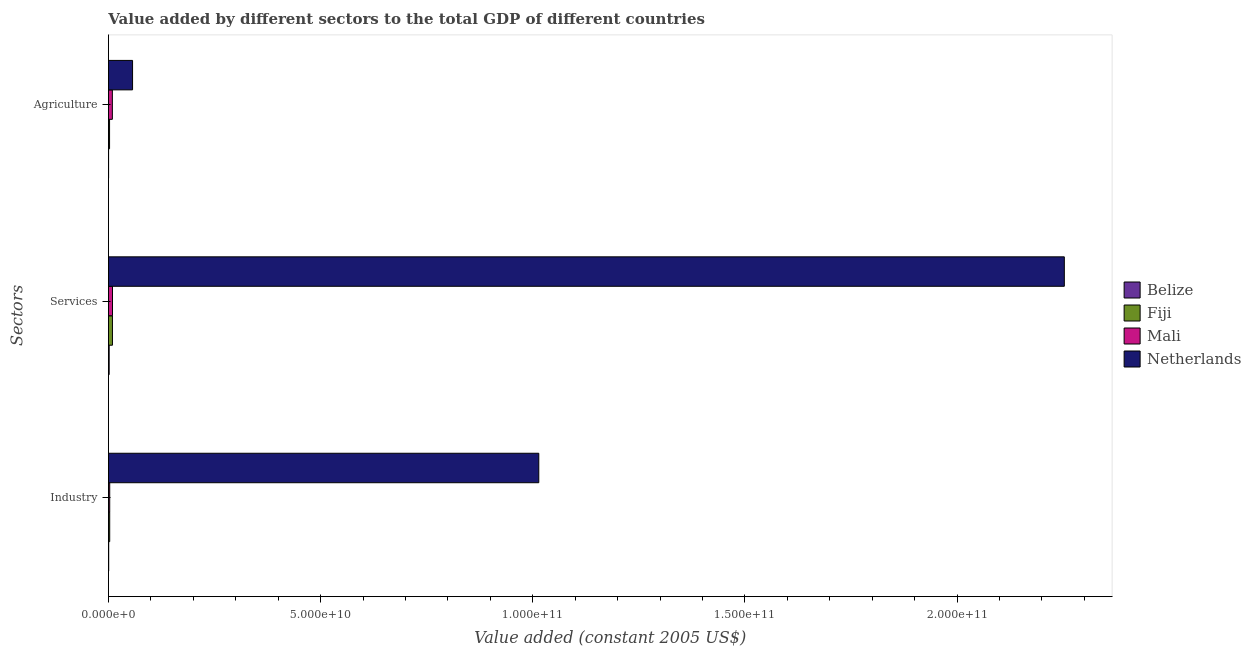How many different coloured bars are there?
Keep it short and to the point. 4. How many bars are there on the 2nd tick from the bottom?
Provide a short and direct response. 4. What is the label of the 2nd group of bars from the top?
Ensure brevity in your answer.  Services. What is the value added by services in Fiji?
Give a very brief answer. 9.49e+08. Across all countries, what is the maximum value added by industrial sector?
Offer a very short reply. 1.01e+11. Across all countries, what is the minimum value added by industrial sector?
Make the answer very short. 6.44e+07. In which country was the value added by industrial sector minimum?
Give a very brief answer. Belize. What is the total value added by services in the graph?
Offer a very short reply. 2.27e+11. What is the difference between the value added by services in Fiji and that in Belize?
Your response must be concise. 7.75e+08. What is the difference between the value added by services in Mali and the value added by industrial sector in Netherlands?
Give a very brief answer. -1.00e+11. What is the average value added by industrial sector per country?
Provide a succinct answer. 2.55e+1. What is the difference between the value added by agricultural sector and value added by industrial sector in Fiji?
Provide a succinct answer. -3.22e+07. What is the ratio of the value added by services in Fiji to that in Mali?
Offer a terse response. 0.99. What is the difference between the highest and the second highest value added by services?
Keep it short and to the point. 2.24e+11. What is the difference between the highest and the lowest value added by services?
Give a very brief answer. 2.25e+11. In how many countries, is the value added by agricultural sector greater than the average value added by agricultural sector taken over all countries?
Offer a very short reply. 1. What does the 2nd bar from the top in Services represents?
Keep it short and to the point. Mali. What does the 1st bar from the bottom in Industry represents?
Provide a succinct answer. Belize. How many countries are there in the graph?
Keep it short and to the point. 4. What is the difference between two consecutive major ticks on the X-axis?
Your response must be concise. 5.00e+1. Does the graph contain any zero values?
Provide a short and direct response. No. Does the graph contain grids?
Ensure brevity in your answer.  No. Where does the legend appear in the graph?
Provide a succinct answer. Center right. What is the title of the graph?
Your answer should be very brief. Value added by different sectors to the total GDP of different countries. Does "Canada" appear as one of the legend labels in the graph?
Offer a terse response. No. What is the label or title of the X-axis?
Make the answer very short. Value added (constant 2005 US$). What is the label or title of the Y-axis?
Ensure brevity in your answer.  Sectors. What is the Value added (constant 2005 US$) of Belize in Industry?
Provide a succinct answer. 6.44e+07. What is the Value added (constant 2005 US$) of Fiji in Industry?
Ensure brevity in your answer.  3.01e+08. What is the Value added (constant 2005 US$) in Mali in Industry?
Keep it short and to the point. 3.04e+08. What is the Value added (constant 2005 US$) in Netherlands in Industry?
Ensure brevity in your answer.  1.01e+11. What is the Value added (constant 2005 US$) in Belize in Services?
Ensure brevity in your answer.  1.75e+08. What is the Value added (constant 2005 US$) of Fiji in Services?
Offer a terse response. 9.49e+08. What is the Value added (constant 2005 US$) of Mali in Services?
Your answer should be very brief. 9.58e+08. What is the Value added (constant 2005 US$) in Netherlands in Services?
Offer a very short reply. 2.25e+11. What is the Value added (constant 2005 US$) in Belize in Agriculture?
Ensure brevity in your answer.  3.76e+07. What is the Value added (constant 2005 US$) of Fiji in Agriculture?
Your response must be concise. 2.69e+08. What is the Value added (constant 2005 US$) of Mali in Agriculture?
Keep it short and to the point. 9.25e+08. What is the Value added (constant 2005 US$) in Netherlands in Agriculture?
Offer a terse response. 5.69e+09. Across all Sectors, what is the maximum Value added (constant 2005 US$) of Belize?
Offer a terse response. 1.75e+08. Across all Sectors, what is the maximum Value added (constant 2005 US$) in Fiji?
Offer a very short reply. 9.49e+08. Across all Sectors, what is the maximum Value added (constant 2005 US$) of Mali?
Offer a very short reply. 9.58e+08. Across all Sectors, what is the maximum Value added (constant 2005 US$) of Netherlands?
Ensure brevity in your answer.  2.25e+11. Across all Sectors, what is the minimum Value added (constant 2005 US$) of Belize?
Make the answer very short. 3.76e+07. Across all Sectors, what is the minimum Value added (constant 2005 US$) of Fiji?
Your answer should be very brief. 2.69e+08. Across all Sectors, what is the minimum Value added (constant 2005 US$) of Mali?
Offer a very short reply. 3.04e+08. Across all Sectors, what is the minimum Value added (constant 2005 US$) in Netherlands?
Your response must be concise. 5.69e+09. What is the total Value added (constant 2005 US$) of Belize in the graph?
Your answer should be very brief. 2.76e+08. What is the total Value added (constant 2005 US$) of Fiji in the graph?
Your answer should be compact. 1.52e+09. What is the total Value added (constant 2005 US$) in Mali in the graph?
Offer a very short reply. 2.19e+09. What is the total Value added (constant 2005 US$) in Netherlands in the graph?
Your response must be concise. 3.32e+11. What is the difference between the Value added (constant 2005 US$) of Belize in Industry and that in Services?
Offer a very short reply. -1.10e+08. What is the difference between the Value added (constant 2005 US$) in Fiji in Industry and that in Services?
Keep it short and to the point. -6.49e+08. What is the difference between the Value added (constant 2005 US$) in Mali in Industry and that in Services?
Keep it short and to the point. -6.53e+08. What is the difference between the Value added (constant 2005 US$) of Netherlands in Industry and that in Services?
Provide a short and direct response. -1.24e+11. What is the difference between the Value added (constant 2005 US$) of Belize in Industry and that in Agriculture?
Your response must be concise. 2.68e+07. What is the difference between the Value added (constant 2005 US$) in Fiji in Industry and that in Agriculture?
Provide a succinct answer. 3.22e+07. What is the difference between the Value added (constant 2005 US$) in Mali in Industry and that in Agriculture?
Your answer should be compact. -6.21e+08. What is the difference between the Value added (constant 2005 US$) of Netherlands in Industry and that in Agriculture?
Keep it short and to the point. 9.57e+1. What is the difference between the Value added (constant 2005 US$) in Belize in Services and that in Agriculture?
Ensure brevity in your answer.  1.37e+08. What is the difference between the Value added (constant 2005 US$) of Fiji in Services and that in Agriculture?
Provide a succinct answer. 6.81e+08. What is the difference between the Value added (constant 2005 US$) in Mali in Services and that in Agriculture?
Offer a terse response. 3.22e+07. What is the difference between the Value added (constant 2005 US$) of Netherlands in Services and that in Agriculture?
Your answer should be very brief. 2.20e+11. What is the difference between the Value added (constant 2005 US$) of Belize in Industry and the Value added (constant 2005 US$) of Fiji in Services?
Ensure brevity in your answer.  -8.85e+08. What is the difference between the Value added (constant 2005 US$) in Belize in Industry and the Value added (constant 2005 US$) in Mali in Services?
Your answer should be compact. -8.93e+08. What is the difference between the Value added (constant 2005 US$) in Belize in Industry and the Value added (constant 2005 US$) in Netherlands in Services?
Give a very brief answer. -2.25e+11. What is the difference between the Value added (constant 2005 US$) of Fiji in Industry and the Value added (constant 2005 US$) of Mali in Services?
Make the answer very short. -6.57e+08. What is the difference between the Value added (constant 2005 US$) of Fiji in Industry and the Value added (constant 2005 US$) of Netherlands in Services?
Your answer should be compact. -2.25e+11. What is the difference between the Value added (constant 2005 US$) of Mali in Industry and the Value added (constant 2005 US$) of Netherlands in Services?
Your response must be concise. -2.25e+11. What is the difference between the Value added (constant 2005 US$) in Belize in Industry and the Value added (constant 2005 US$) in Fiji in Agriculture?
Your answer should be very brief. -2.04e+08. What is the difference between the Value added (constant 2005 US$) in Belize in Industry and the Value added (constant 2005 US$) in Mali in Agriculture?
Offer a very short reply. -8.61e+08. What is the difference between the Value added (constant 2005 US$) in Belize in Industry and the Value added (constant 2005 US$) in Netherlands in Agriculture?
Ensure brevity in your answer.  -5.62e+09. What is the difference between the Value added (constant 2005 US$) in Fiji in Industry and the Value added (constant 2005 US$) in Mali in Agriculture?
Provide a short and direct response. -6.25e+08. What is the difference between the Value added (constant 2005 US$) in Fiji in Industry and the Value added (constant 2005 US$) in Netherlands in Agriculture?
Provide a short and direct response. -5.39e+09. What is the difference between the Value added (constant 2005 US$) in Mali in Industry and the Value added (constant 2005 US$) in Netherlands in Agriculture?
Your answer should be compact. -5.38e+09. What is the difference between the Value added (constant 2005 US$) in Belize in Services and the Value added (constant 2005 US$) in Fiji in Agriculture?
Provide a short and direct response. -9.41e+07. What is the difference between the Value added (constant 2005 US$) of Belize in Services and the Value added (constant 2005 US$) of Mali in Agriculture?
Offer a terse response. -7.51e+08. What is the difference between the Value added (constant 2005 US$) of Belize in Services and the Value added (constant 2005 US$) of Netherlands in Agriculture?
Provide a short and direct response. -5.51e+09. What is the difference between the Value added (constant 2005 US$) of Fiji in Services and the Value added (constant 2005 US$) of Mali in Agriculture?
Ensure brevity in your answer.  2.41e+07. What is the difference between the Value added (constant 2005 US$) of Fiji in Services and the Value added (constant 2005 US$) of Netherlands in Agriculture?
Provide a short and direct response. -4.74e+09. What is the difference between the Value added (constant 2005 US$) in Mali in Services and the Value added (constant 2005 US$) in Netherlands in Agriculture?
Your response must be concise. -4.73e+09. What is the average Value added (constant 2005 US$) in Belize per Sectors?
Offer a very short reply. 9.22e+07. What is the average Value added (constant 2005 US$) in Fiji per Sectors?
Make the answer very short. 5.06e+08. What is the average Value added (constant 2005 US$) of Mali per Sectors?
Your response must be concise. 7.29e+08. What is the average Value added (constant 2005 US$) of Netherlands per Sectors?
Make the answer very short. 1.11e+11. What is the difference between the Value added (constant 2005 US$) in Belize and Value added (constant 2005 US$) in Fiji in Industry?
Keep it short and to the point. -2.36e+08. What is the difference between the Value added (constant 2005 US$) of Belize and Value added (constant 2005 US$) of Mali in Industry?
Provide a succinct answer. -2.40e+08. What is the difference between the Value added (constant 2005 US$) in Belize and Value added (constant 2005 US$) in Netherlands in Industry?
Your answer should be very brief. -1.01e+11. What is the difference between the Value added (constant 2005 US$) in Fiji and Value added (constant 2005 US$) in Mali in Industry?
Make the answer very short. -3.46e+06. What is the difference between the Value added (constant 2005 US$) in Fiji and Value added (constant 2005 US$) in Netherlands in Industry?
Your response must be concise. -1.01e+11. What is the difference between the Value added (constant 2005 US$) of Mali and Value added (constant 2005 US$) of Netherlands in Industry?
Offer a very short reply. -1.01e+11. What is the difference between the Value added (constant 2005 US$) of Belize and Value added (constant 2005 US$) of Fiji in Services?
Ensure brevity in your answer.  -7.75e+08. What is the difference between the Value added (constant 2005 US$) in Belize and Value added (constant 2005 US$) in Mali in Services?
Offer a terse response. -7.83e+08. What is the difference between the Value added (constant 2005 US$) of Belize and Value added (constant 2005 US$) of Netherlands in Services?
Ensure brevity in your answer.  -2.25e+11. What is the difference between the Value added (constant 2005 US$) of Fiji and Value added (constant 2005 US$) of Mali in Services?
Offer a very short reply. -8.07e+06. What is the difference between the Value added (constant 2005 US$) in Fiji and Value added (constant 2005 US$) in Netherlands in Services?
Make the answer very short. -2.24e+11. What is the difference between the Value added (constant 2005 US$) of Mali and Value added (constant 2005 US$) of Netherlands in Services?
Your answer should be compact. -2.24e+11. What is the difference between the Value added (constant 2005 US$) in Belize and Value added (constant 2005 US$) in Fiji in Agriculture?
Your response must be concise. -2.31e+08. What is the difference between the Value added (constant 2005 US$) of Belize and Value added (constant 2005 US$) of Mali in Agriculture?
Ensure brevity in your answer.  -8.88e+08. What is the difference between the Value added (constant 2005 US$) in Belize and Value added (constant 2005 US$) in Netherlands in Agriculture?
Provide a short and direct response. -5.65e+09. What is the difference between the Value added (constant 2005 US$) of Fiji and Value added (constant 2005 US$) of Mali in Agriculture?
Your answer should be compact. -6.57e+08. What is the difference between the Value added (constant 2005 US$) of Fiji and Value added (constant 2005 US$) of Netherlands in Agriculture?
Keep it short and to the point. -5.42e+09. What is the difference between the Value added (constant 2005 US$) of Mali and Value added (constant 2005 US$) of Netherlands in Agriculture?
Provide a succinct answer. -4.76e+09. What is the ratio of the Value added (constant 2005 US$) in Belize in Industry to that in Services?
Provide a succinct answer. 0.37. What is the ratio of the Value added (constant 2005 US$) in Fiji in Industry to that in Services?
Offer a terse response. 0.32. What is the ratio of the Value added (constant 2005 US$) of Mali in Industry to that in Services?
Offer a very short reply. 0.32. What is the ratio of the Value added (constant 2005 US$) in Netherlands in Industry to that in Services?
Ensure brevity in your answer.  0.45. What is the ratio of the Value added (constant 2005 US$) in Belize in Industry to that in Agriculture?
Your answer should be compact. 1.71. What is the ratio of the Value added (constant 2005 US$) in Fiji in Industry to that in Agriculture?
Offer a very short reply. 1.12. What is the ratio of the Value added (constant 2005 US$) in Mali in Industry to that in Agriculture?
Offer a terse response. 0.33. What is the ratio of the Value added (constant 2005 US$) of Netherlands in Industry to that in Agriculture?
Your answer should be compact. 17.84. What is the ratio of the Value added (constant 2005 US$) of Belize in Services to that in Agriculture?
Provide a succinct answer. 4.64. What is the ratio of the Value added (constant 2005 US$) in Fiji in Services to that in Agriculture?
Your answer should be compact. 3.54. What is the ratio of the Value added (constant 2005 US$) in Mali in Services to that in Agriculture?
Your answer should be very brief. 1.03. What is the ratio of the Value added (constant 2005 US$) in Netherlands in Services to that in Agriculture?
Provide a succinct answer. 39.62. What is the difference between the highest and the second highest Value added (constant 2005 US$) of Belize?
Your answer should be compact. 1.10e+08. What is the difference between the highest and the second highest Value added (constant 2005 US$) in Fiji?
Make the answer very short. 6.49e+08. What is the difference between the highest and the second highest Value added (constant 2005 US$) in Mali?
Ensure brevity in your answer.  3.22e+07. What is the difference between the highest and the second highest Value added (constant 2005 US$) in Netherlands?
Ensure brevity in your answer.  1.24e+11. What is the difference between the highest and the lowest Value added (constant 2005 US$) of Belize?
Make the answer very short. 1.37e+08. What is the difference between the highest and the lowest Value added (constant 2005 US$) of Fiji?
Provide a succinct answer. 6.81e+08. What is the difference between the highest and the lowest Value added (constant 2005 US$) in Mali?
Make the answer very short. 6.53e+08. What is the difference between the highest and the lowest Value added (constant 2005 US$) in Netherlands?
Make the answer very short. 2.20e+11. 